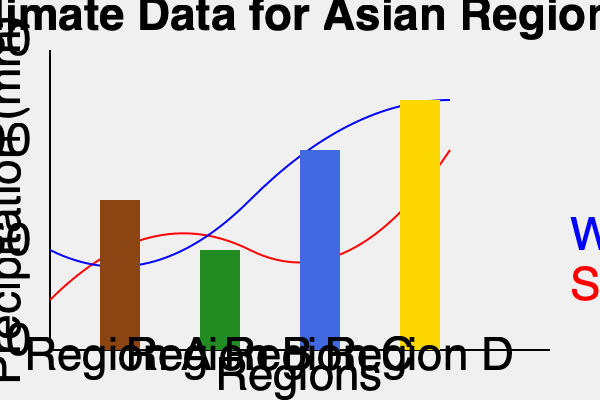Based on the climate data presented in the graph for various Asian regions, which region shows the greatest seasonal temperature variation and the highest annual precipitation? To answer this question, we need to analyze both the temperature curves and precipitation bars for each region:

1. Temperature variation:
   - Look at the difference between the red (summer) and blue (winter) curves for each region.
   - Region D shows the largest gap between summer and winter temperatures.

2. Annual precipitation:
   - Compare the heights of the bars for each region.
   - Region D has the tallest bar, indicating the highest annual precipitation.

3. Analyzing each region:
   - Region A: Moderate temperature variation, low precipitation
   - Region B: Small temperature variation, moderate precipitation
   - Region C: Moderate temperature variation, high precipitation
   - Region D: Large temperature variation, highest precipitation

4. Conclusion:
   Region D exhibits both the greatest seasonal temperature variation (largest gap between red and blue curves) and the highest annual precipitation (tallest bar).
Answer: Region D 